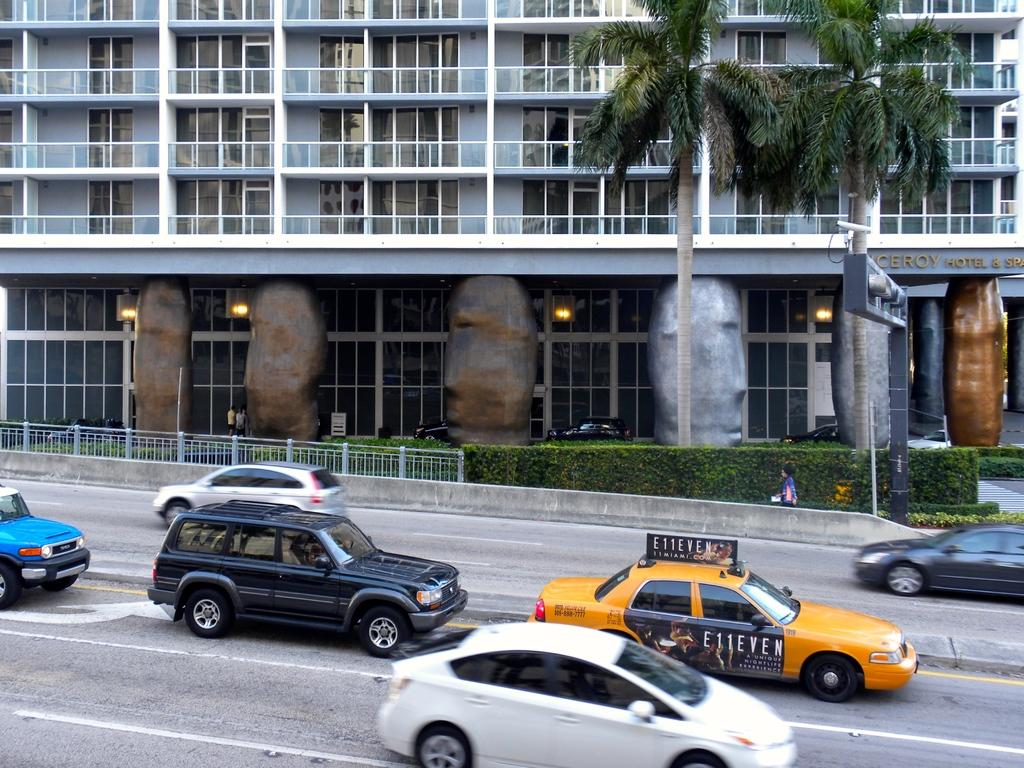Provide a one-sentence caption for the provided image. A taxi cab in a large city advertises for E11EVEN. 